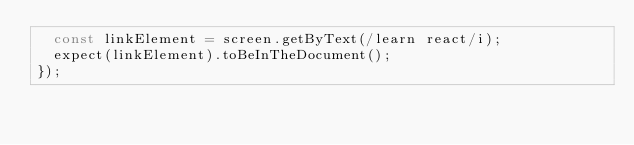<code> <loc_0><loc_0><loc_500><loc_500><_JavaScript_>  const linkElement = screen.getByText(/learn react/i);
  expect(linkElement).toBeInTheDocument();
});
</code> 